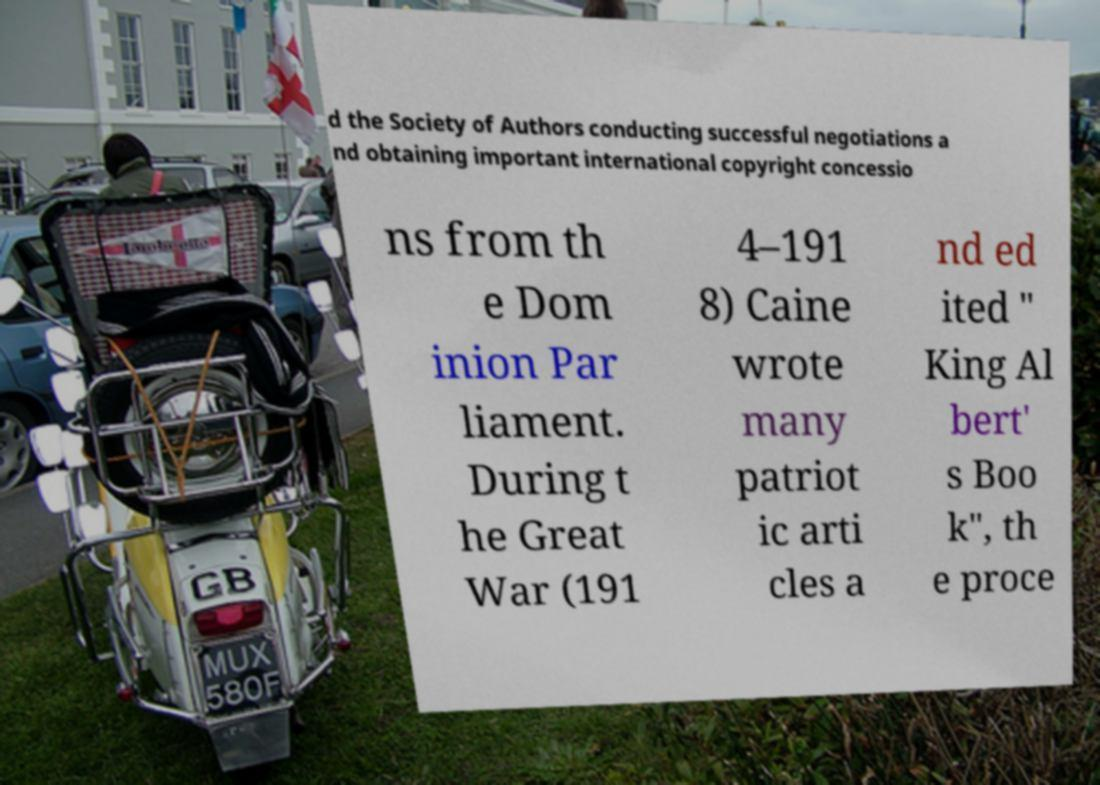Could you assist in decoding the text presented in this image and type it out clearly? d the Society of Authors conducting successful negotiations a nd obtaining important international copyright concessio ns from th e Dom inion Par liament. During t he Great War (191 4–191 8) Caine wrote many patriot ic arti cles a nd ed ited " King Al bert' s Boo k", th e proce 